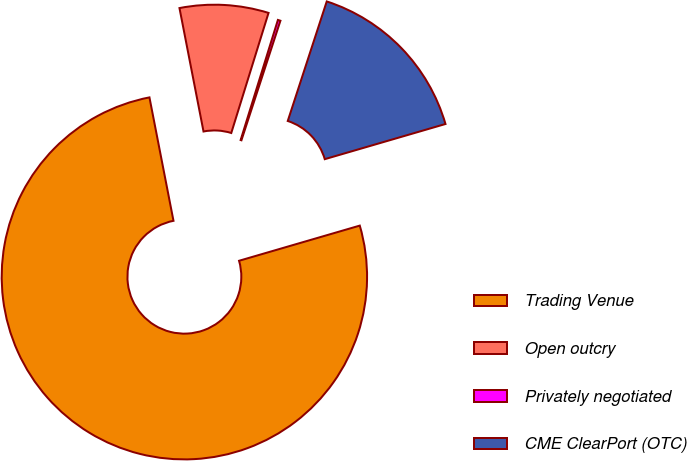Convert chart to OTSL. <chart><loc_0><loc_0><loc_500><loc_500><pie_chart><fcel>Trading Venue<fcel>Open outcry<fcel>Privately negotiated<fcel>CME ClearPort (OTC)<nl><fcel>76.45%<fcel>7.85%<fcel>0.23%<fcel>15.47%<nl></chart> 